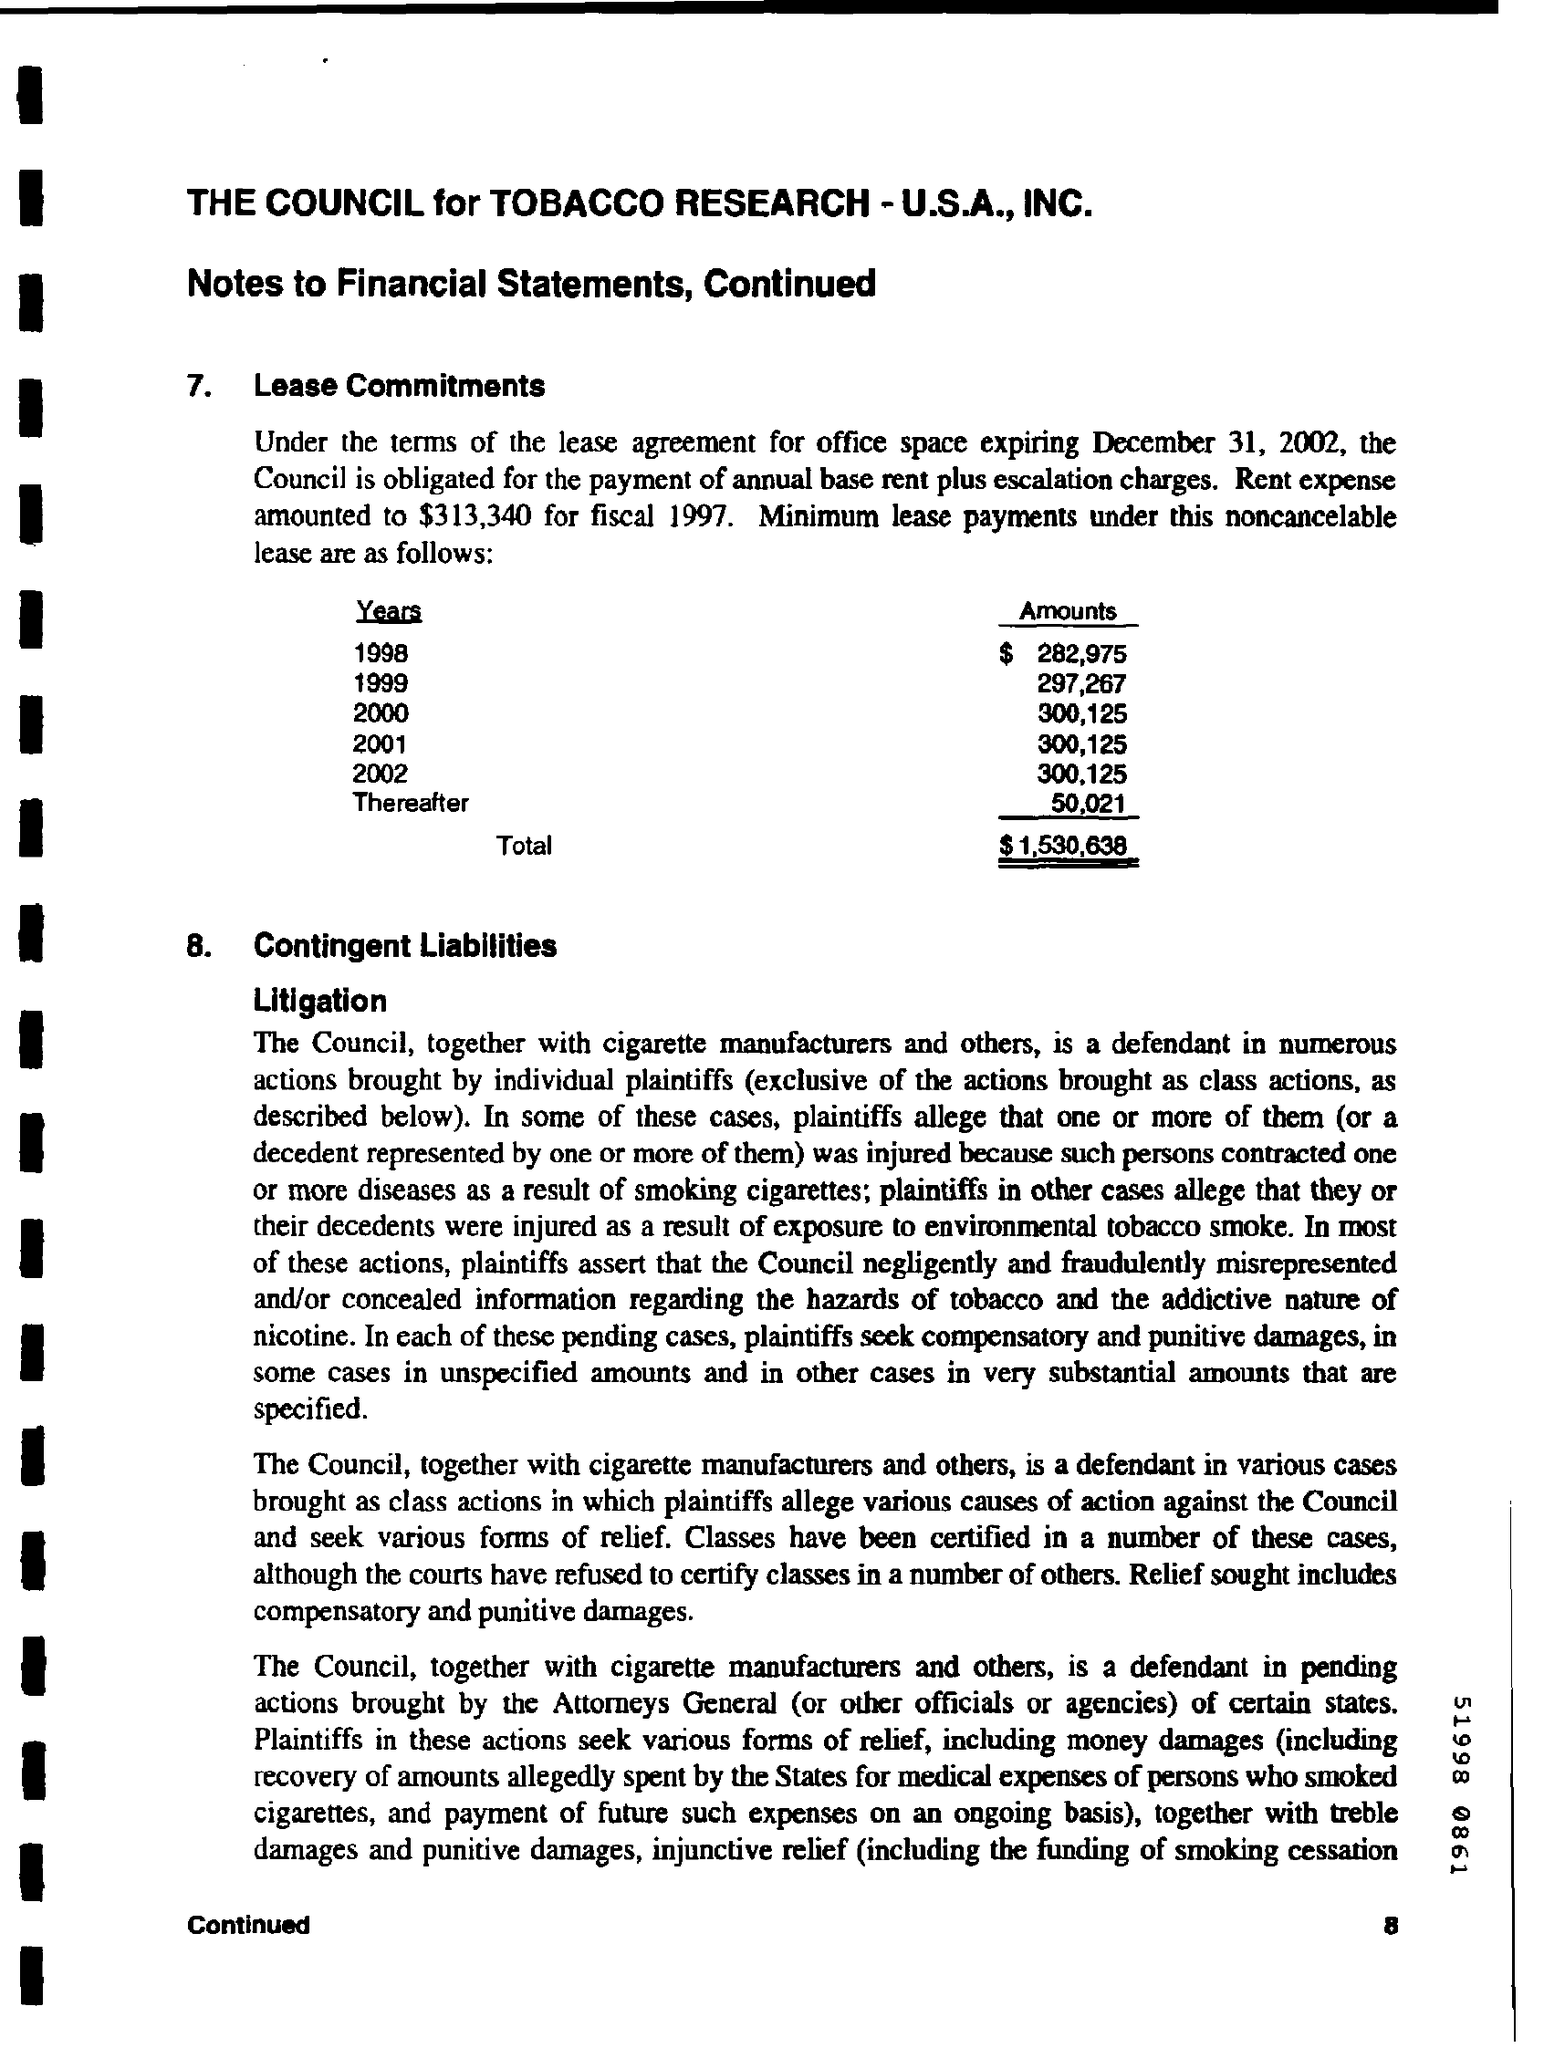Specify some key components in this picture. The total amount mentioned in the given form is $1,530,638. The amounts given for the year 2002 are 300,125. The amounts given for the year 2001 are 300,125. For the year 1998, the amount given was 282,975... The amounts given for the year 2000 are 300,125. 